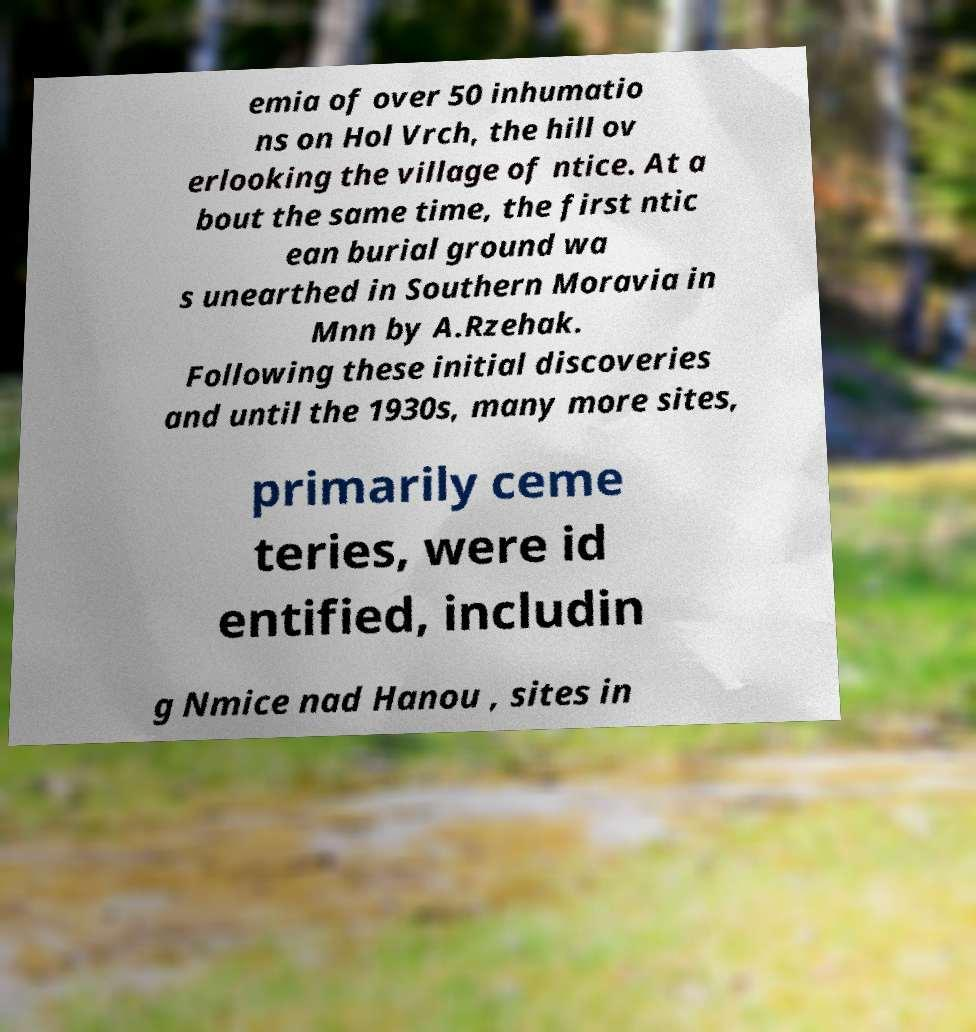Please read and relay the text visible in this image. What does it say? emia of over 50 inhumatio ns on Hol Vrch, the hill ov erlooking the village of ntice. At a bout the same time, the first ntic ean burial ground wa s unearthed in Southern Moravia in Mnn by A.Rzehak. Following these initial discoveries and until the 1930s, many more sites, primarily ceme teries, were id entified, includin g Nmice nad Hanou , sites in 